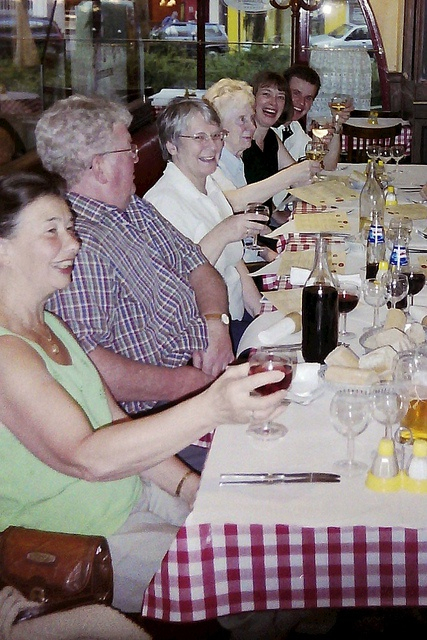Describe the objects in this image and their specific colors. I can see dining table in gray, darkgray, lightgray, black, and maroon tones, people in gray, darkgray, beige, and lightgray tones, people in gray and darkgray tones, people in gray, darkgray, lightgray, and black tones, and handbag in gray, maroon, black, and brown tones in this image. 